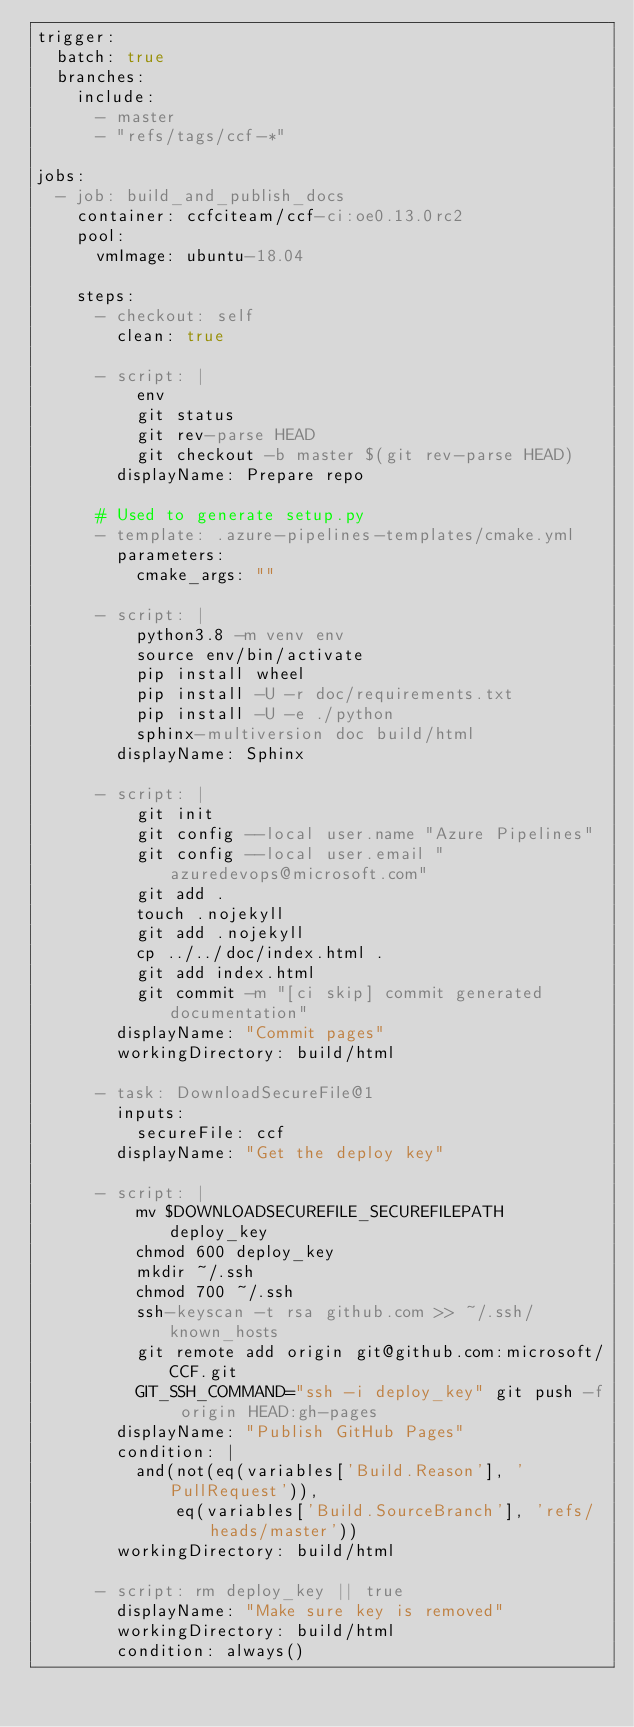Convert code to text. <code><loc_0><loc_0><loc_500><loc_500><_YAML_>trigger:
  batch: true
  branches:
    include:
      - master
      - "refs/tags/ccf-*"

jobs:
  - job: build_and_publish_docs
    container: ccfciteam/ccf-ci:oe0.13.0rc2
    pool:
      vmImage: ubuntu-18.04

    steps:
      - checkout: self
        clean: true

      - script: |
          env
          git status
          git rev-parse HEAD
          git checkout -b master $(git rev-parse HEAD)
        displayName: Prepare repo

      # Used to generate setup.py
      - template: .azure-pipelines-templates/cmake.yml
        parameters:
          cmake_args: ""

      - script: |
          python3.8 -m venv env
          source env/bin/activate
          pip install wheel
          pip install -U -r doc/requirements.txt
          pip install -U -e ./python
          sphinx-multiversion doc build/html
        displayName: Sphinx

      - script: |
          git init
          git config --local user.name "Azure Pipelines"
          git config --local user.email "azuredevops@microsoft.com"
          git add .
          touch .nojekyll
          git add .nojekyll
          cp ../../doc/index.html .
          git add index.html
          git commit -m "[ci skip] commit generated documentation"
        displayName: "Commit pages"
        workingDirectory: build/html

      - task: DownloadSecureFile@1
        inputs:
          secureFile: ccf
        displayName: "Get the deploy key"

      - script: |
          mv $DOWNLOADSECUREFILE_SECUREFILEPATH deploy_key
          chmod 600 deploy_key
          mkdir ~/.ssh
          chmod 700 ~/.ssh
          ssh-keyscan -t rsa github.com >> ~/.ssh/known_hosts
          git remote add origin git@github.com:microsoft/CCF.git
          GIT_SSH_COMMAND="ssh -i deploy_key" git push -f origin HEAD:gh-pages
        displayName: "Publish GitHub Pages"
        condition: |
          and(not(eq(variables['Build.Reason'], 'PullRequest')),
              eq(variables['Build.SourceBranch'], 'refs/heads/master'))
        workingDirectory: build/html

      - script: rm deploy_key || true
        displayName: "Make sure key is removed"
        workingDirectory: build/html
        condition: always()
</code> 